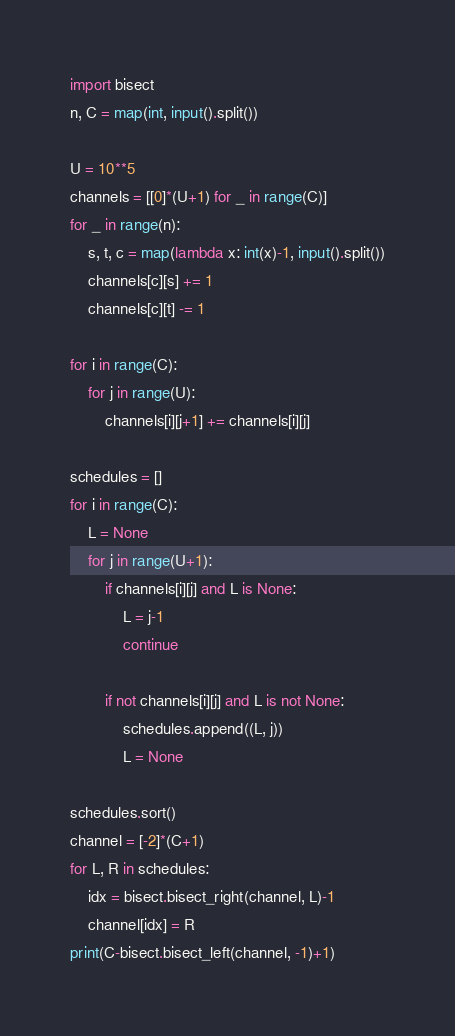Convert code to text. <code><loc_0><loc_0><loc_500><loc_500><_Python_>import bisect
n, C = map(int, input().split())

U = 10**5
channels = [[0]*(U+1) for _ in range(C)]
for _ in range(n):
    s, t, c = map(lambda x: int(x)-1, input().split())
    channels[c][s] += 1
    channels[c][t] -= 1

for i in range(C):
    for j in range(U):
        channels[i][j+1] += channels[i][j]

schedules = []
for i in range(C):
    L = None
    for j in range(U+1):
        if channels[i][j] and L is None:
            L = j-1
            continue

        if not channels[i][j] and L is not None:
            schedules.append((L, j))
            L = None

schedules.sort()
channel = [-2]*(C+1)
for L, R in schedules:
    idx = bisect.bisect_right(channel, L)-1
    channel[idx] = R
print(C-bisect.bisect_left(channel, -1)+1)
</code> 